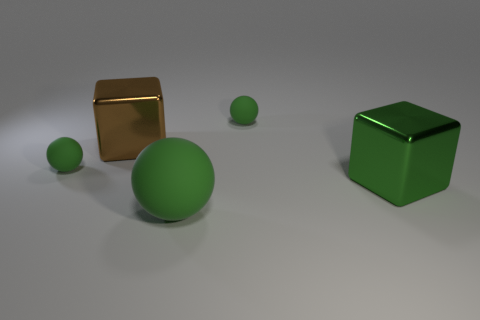Subtract all tiny green spheres. How many spheres are left? 1 Subtract all cubes. How many objects are left? 3 Subtract 1 blocks. How many blocks are left? 1 Subtract all brown blocks. How many blocks are left? 1 Add 1 large matte cylinders. How many objects exist? 6 Subtract all big green rubber balls. Subtract all green things. How many objects are left? 0 Add 5 green matte things. How many green matte things are left? 8 Add 5 large shiny blocks. How many large shiny blocks exist? 7 Subtract 0 blue cylinders. How many objects are left? 5 Subtract all blue blocks. Subtract all blue cylinders. How many blocks are left? 2 